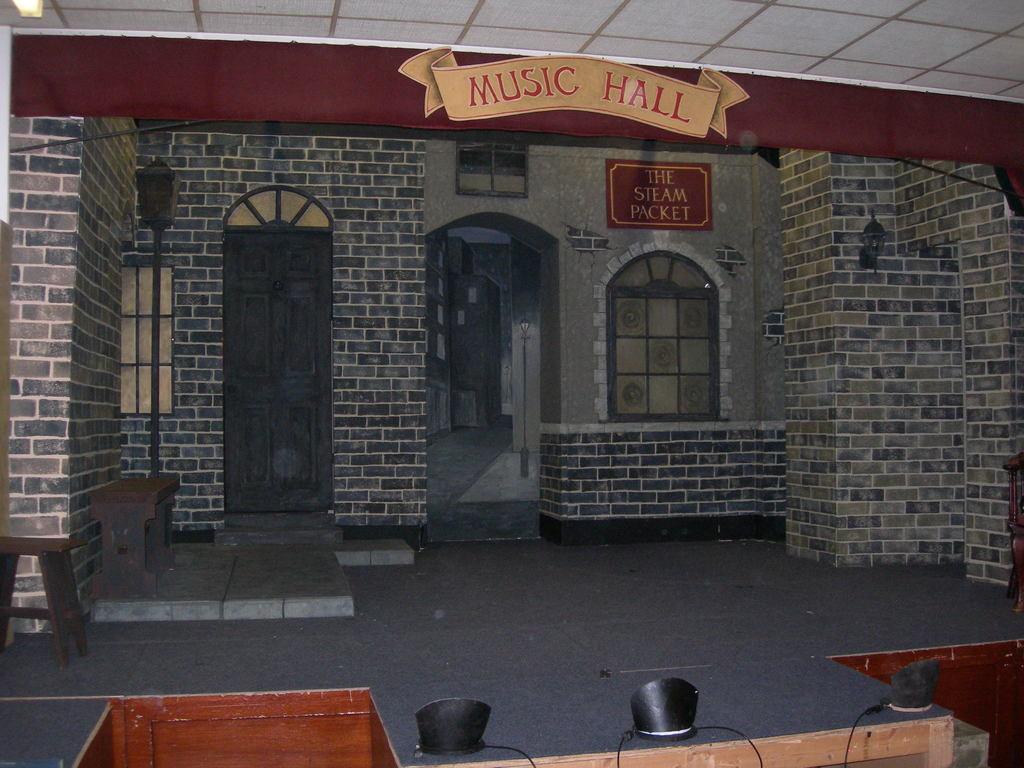Could you give a brief overview of what you see in this image? In this picture there is a music hall in the center of the image and there are benches on the left side of the image. 